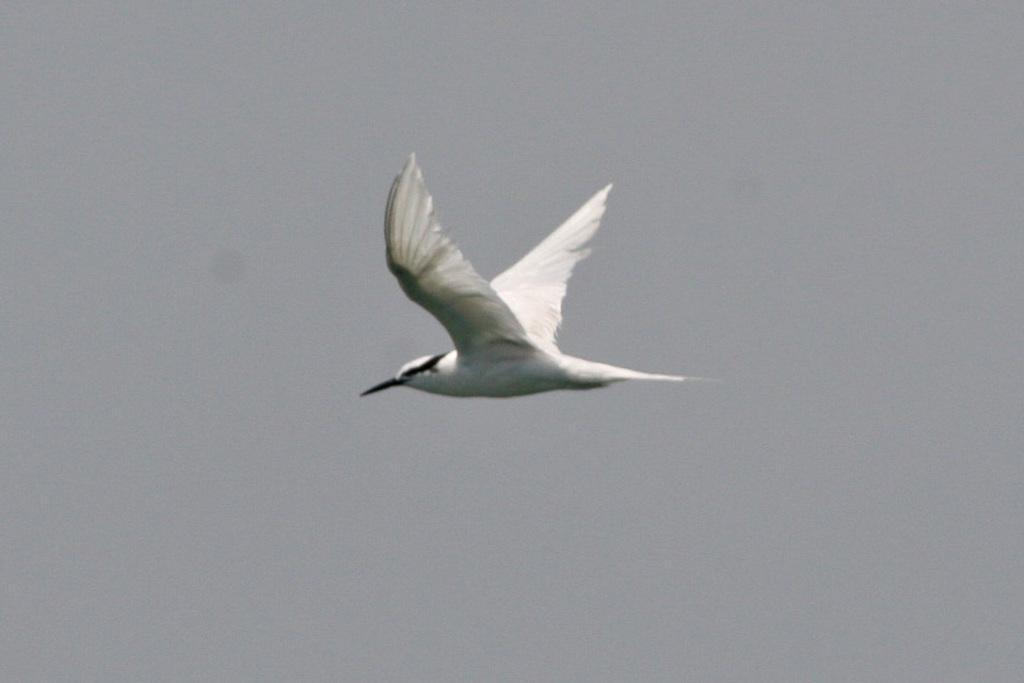Please provide a concise description of this image. In the center of the image we can see a bird flying in the sky. 